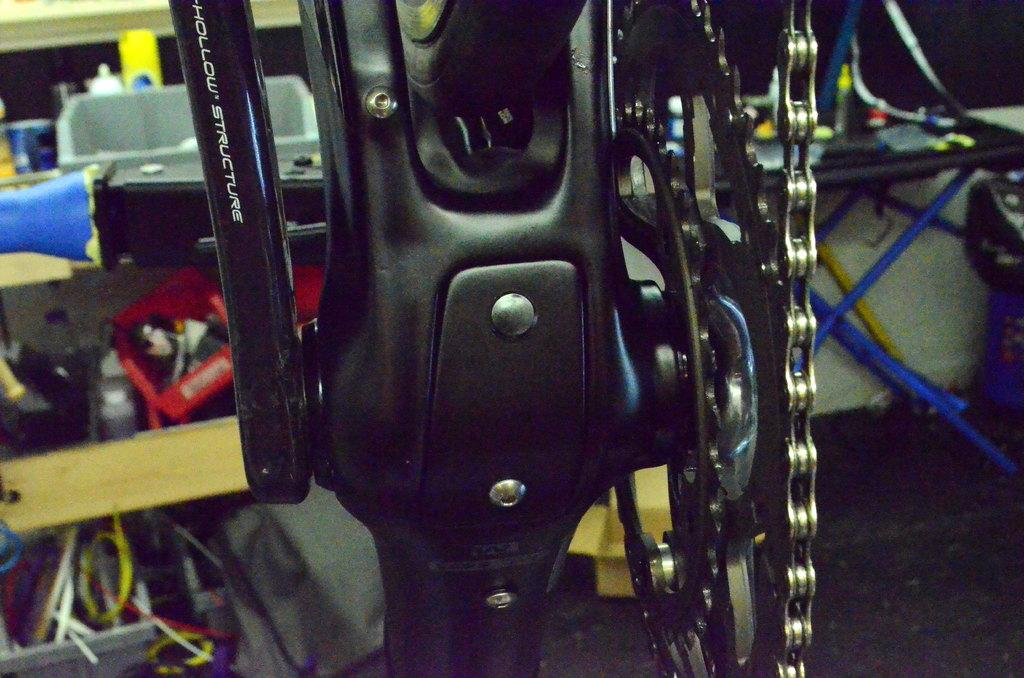What is the main object in the image? There is a bicycle chain in the image. What other objects can be seen in the image? There is a table, wires, a wall, and a pillar in the image. Can you describe the setting of the image? The image may have been taken in a showroom. How far away is the rain from the image? There is no rain present in the image, so it cannot be determined how far away it is. 